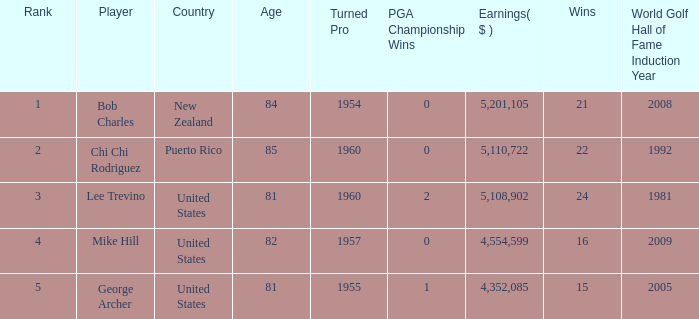What is the lowest level of Earnings($) to have a Wins value of 22 and a Rank lower than 2? None. 